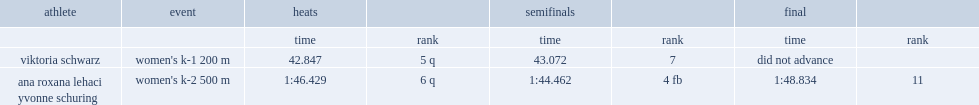What was ana roxana lehaci yvonne schuring's rank in the final? 11.0. 